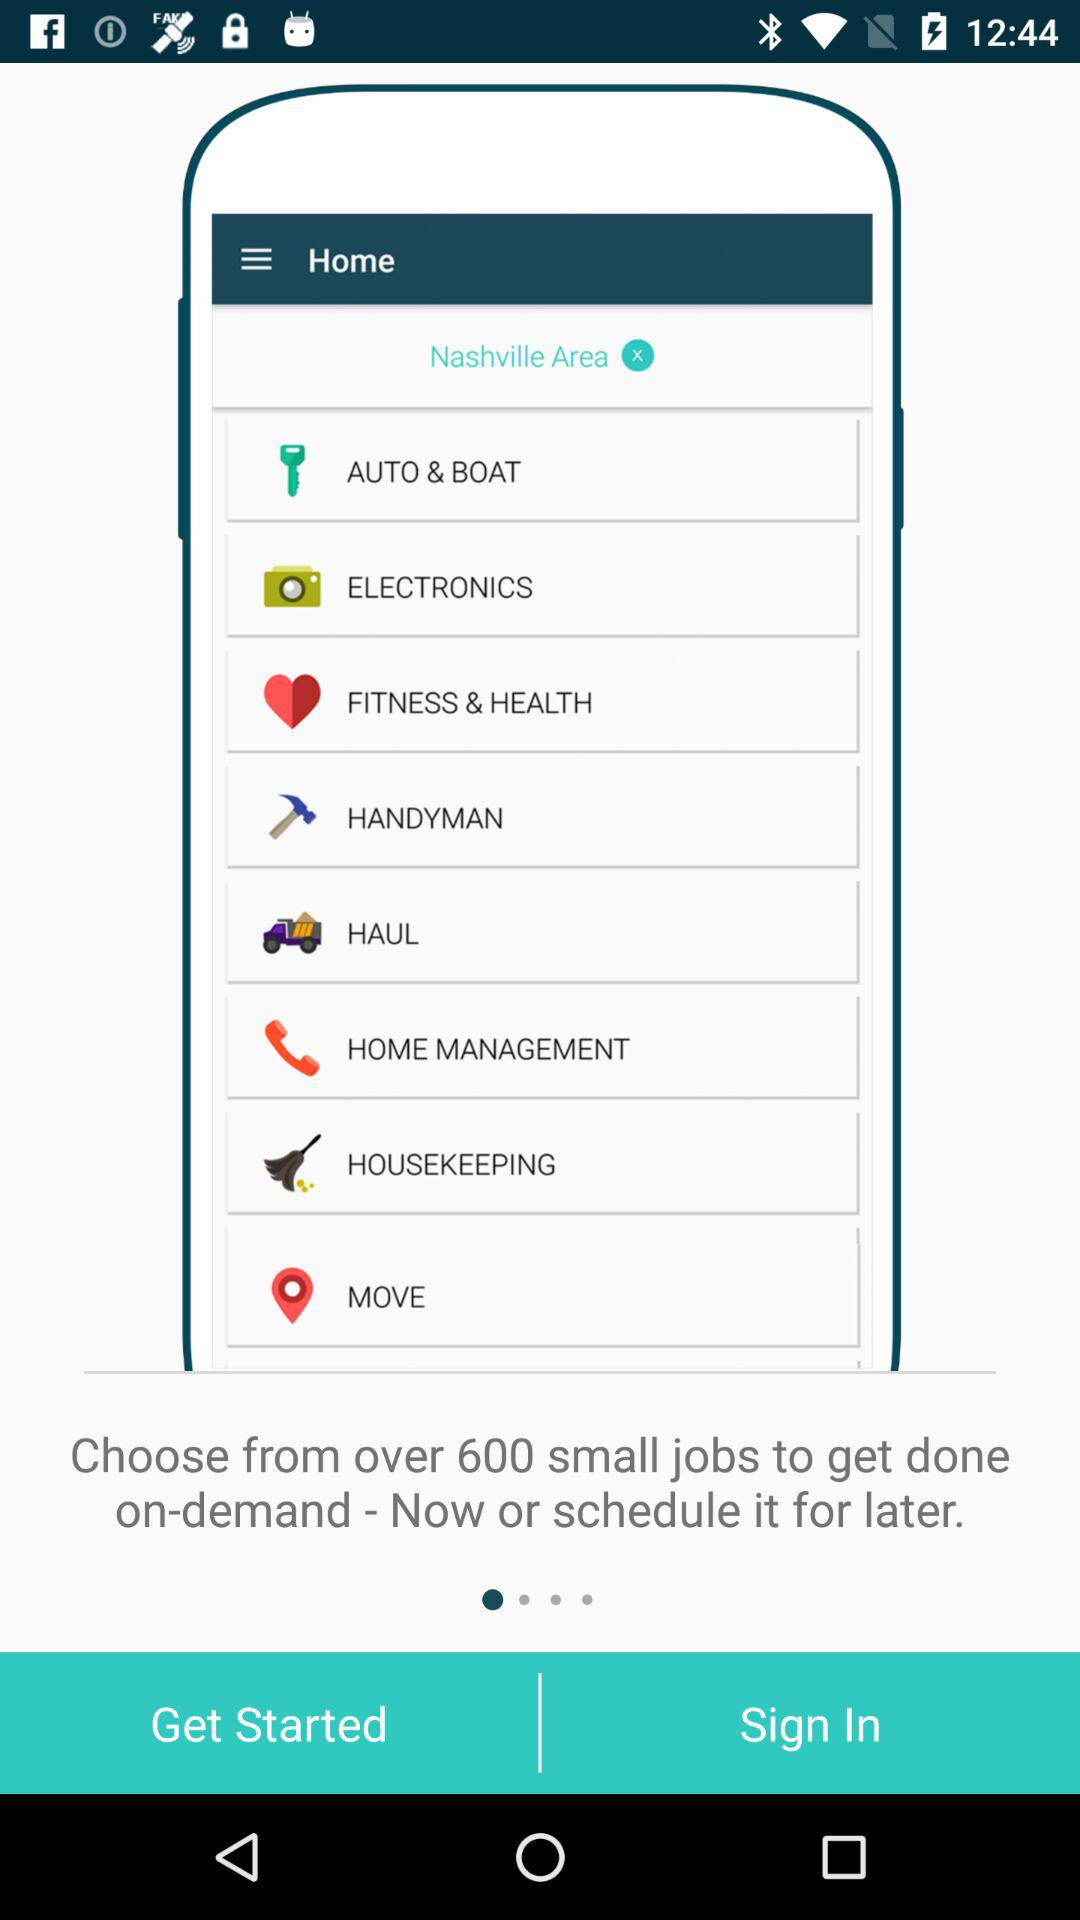How many small jobs are there on demand? There are over 600 small jobs on demand. 